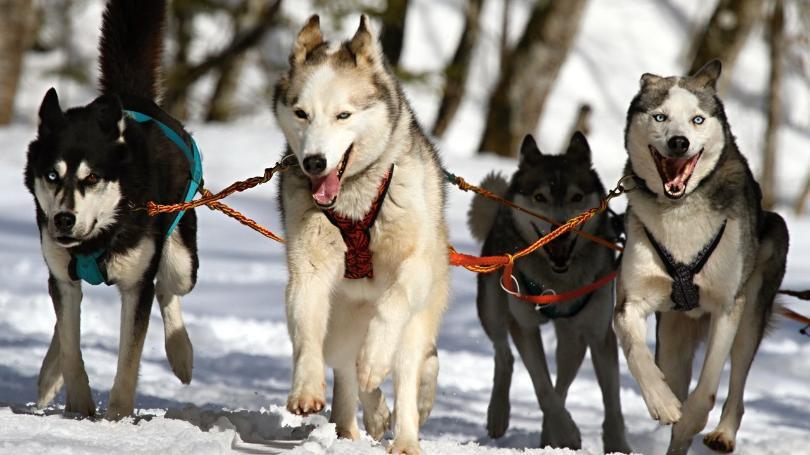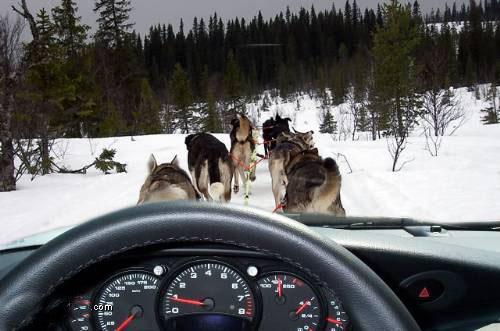The first image is the image on the left, the second image is the image on the right. For the images shown, is this caption "The exterior of a motorized vehicle is visible behind sled dogs in at least one image." true? Answer yes or no. No. The first image is the image on the left, the second image is the image on the right. For the images shown, is this caption "An SUV can be seen in the background on at least one of the images." true? Answer yes or no. No. 